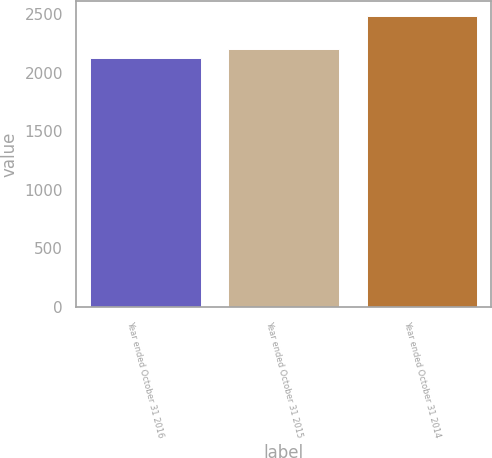Convert chart. <chart><loc_0><loc_0><loc_500><loc_500><bar_chart><fcel>Year ended October 31 2016<fcel>Year ended October 31 2015<fcel>Year ended October 31 2014<nl><fcel>2130<fcel>2199<fcel>2486<nl></chart> 